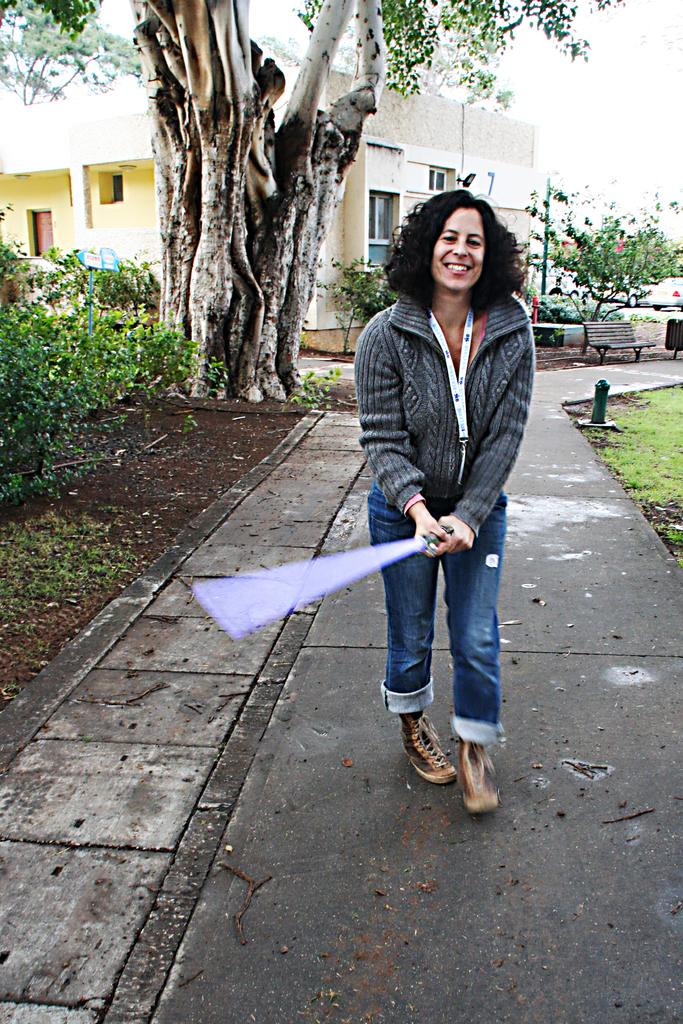What is the primary subject of the image? There is a woman in the image. What is the woman holding in her hands? The woman is holding something in her hands, but the specific object is not mentioned in the facts. What is the woman doing in the image? The woman is walking on the road. What type of vegetation can be seen in the image? There are plants, grass, and trees visible in the image. What type of seating is present in the image? There is a wooden bench in the image. What structures are visible in the background of the image? There is a house and trees in the background of the image. What part of the natural environment is visible in the image? The sky is visible in the background of the image. Is the woman playing a guitar in the image? There is no mention of a guitar in the image, so it cannot be determined if the woman is playing one. 